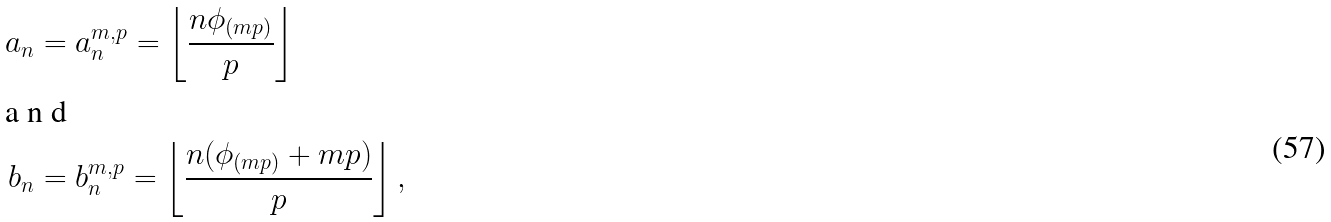Convert formula to latex. <formula><loc_0><loc_0><loc_500><loc_500>a _ { n } & = a _ { n } ^ { m , p } = \left \lfloor \frac { n \phi _ { ( m p ) } } { p } \right \rfloor \intertext { a n d } b _ { n } & = b _ { n } ^ { m , p } = \left \lfloor \frac { n ( \phi _ { ( m p ) } + m p ) } { p } \right \rfloor ,</formula> 